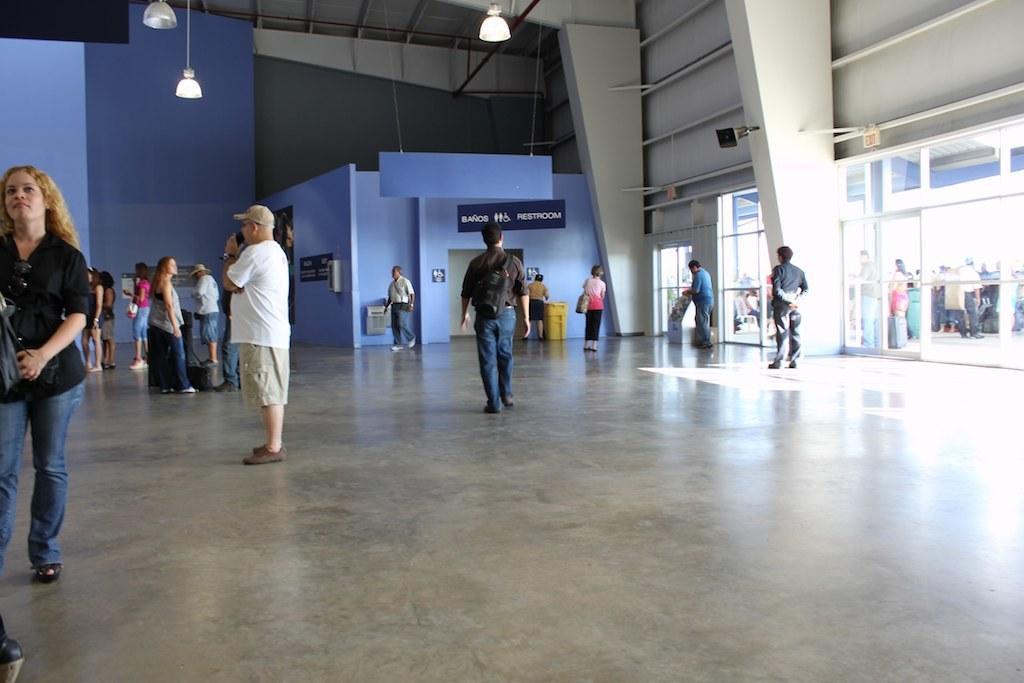How would you summarize this image in a sentence or two? There are many people. In the back there is a room. Near to that there is a dustbin. On the ceiling there are lights. 